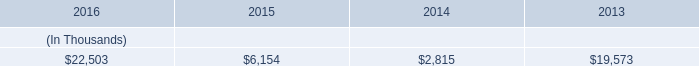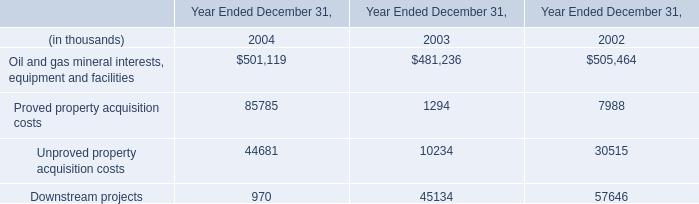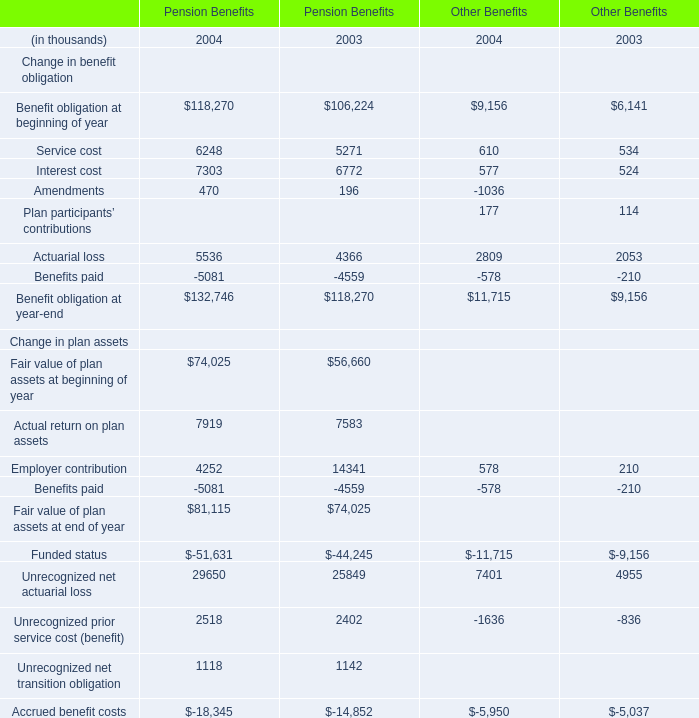When is Fair value of plan assets at beginning of year for Pension Benefits the largest? 
Answer: 2004. 